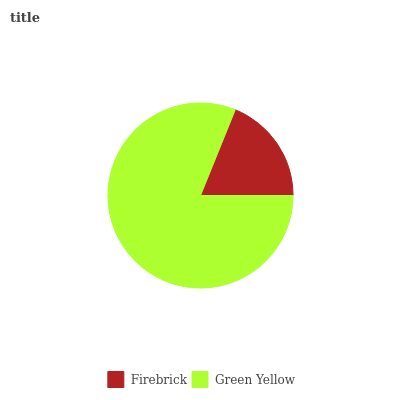Is Firebrick the minimum?
Answer yes or no. Yes. Is Green Yellow the maximum?
Answer yes or no. Yes. Is Green Yellow the minimum?
Answer yes or no. No. Is Green Yellow greater than Firebrick?
Answer yes or no. Yes. Is Firebrick less than Green Yellow?
Answer yes or no. Yes. Is Firebrick greater than Green Yellow?
Answer yes or no. No. Is Green Yellow less than Firebrick?
Answer yes or no. No. Is Green Yellow the high median?
Answer yes or no. Yes. Is Firebrick the low median?
Answer yes or no. Yes. Is Firebrick the high median?
Answer yes or no. No. Is Green Yellow the low median?
Answer yes or no. No. 